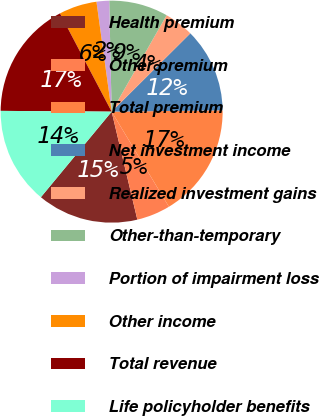Convert chart. <chart><loc_0><loc_0><loc_500><loc_500><pie_chart><fcel>Health premium<fcel>Other premium<fcel>Total premium<fcel>Net investment income<fcel>Realized investment gains<fcel>Other-than-temporary<fcel>Portion of impairment loss<fcel>Other income<fcel>Total revenue<fcel>Life policyholder benefits<nl><fcel>14.72%<fcel>4.91%<fcel>16.56%<fcel>12.27%<fcel>4.29%<fcel>8.59%<fcel>1.84%<fcel>5.52%<fcel>17.18%<fcel>14.11%<nl></chart> 